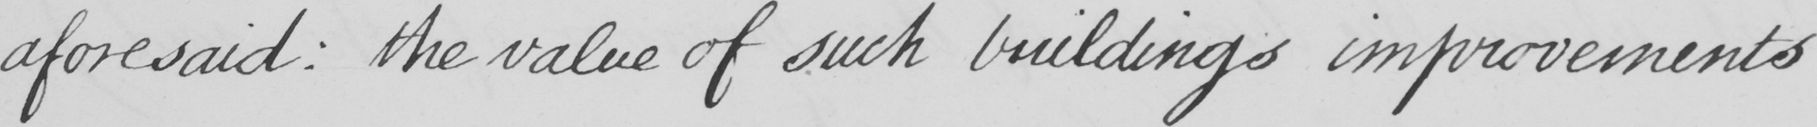Please provide the text content of this handwritten line. aforesaid :  the value of such buildings improvements 